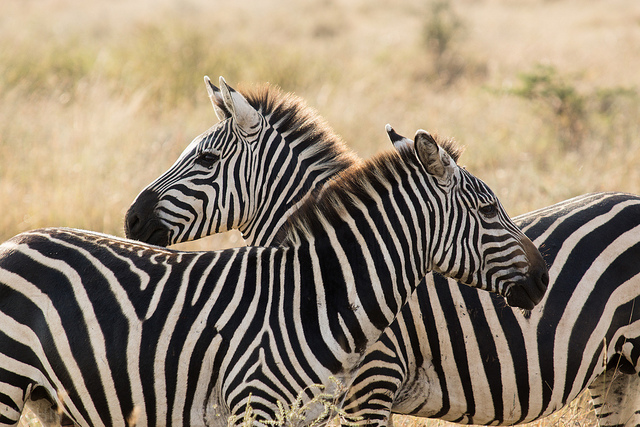How many zebras are in this picture? There are two zebras in this picture. 